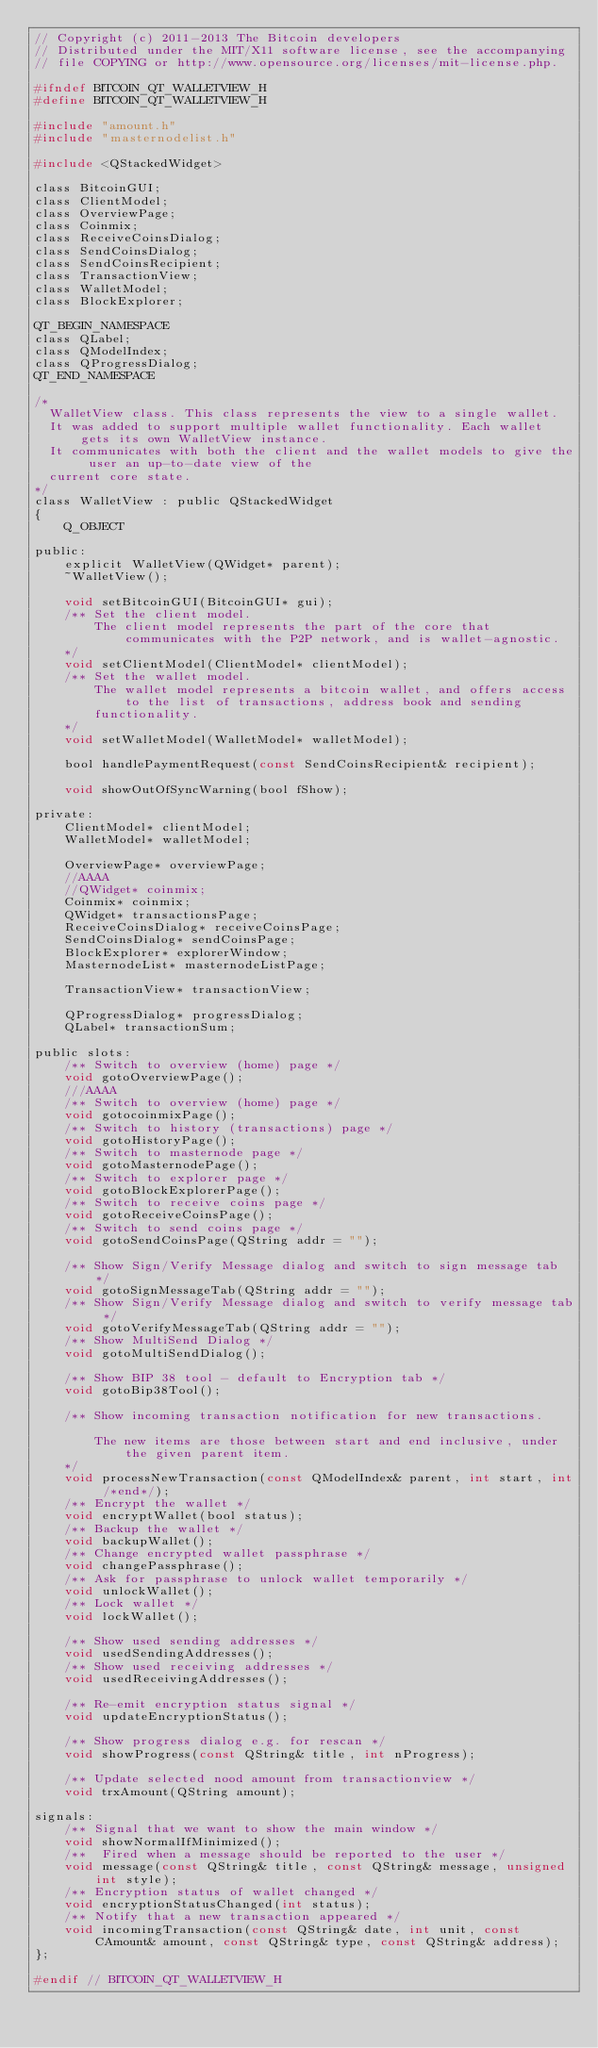<code> <loc_0><loc_0><loc_500><loc_500><_C_>// Copyright (c) 2011-2013 The Bitcoin developers
// Distributed under the MIT/X11 software license, see the accompanying
// file COPYING or http://www.opensource.org/licenses/mit-license.php.

#ifndef BITCOIN_QT_WALLETVIEW_H
#define BITCOIN_QT_WALLETVIEW_H

#include "amount.h"
#include "masternodelist.h"

#include <QStackedWidget>

class BitcoinGUI;
class ClientModel;
class OverviewPage;
class Coinmix;
class ReceiveCoinsDialog;
class SendCoinsDialog;
class SendCoinsRecipient;
class TransactionView;
class WalletModel;
class BlockExplorer;

QT_BEGIN_NAMESPACE
class QLabel;
class QModelIndex;
class QProgressDialog;
QT_END_NAMESPACE

/*
  WalletView class. This class represents the view to a single wallet.
  It was added to support multiple wallet functionality. Each wallet gets its own WalletView instance.
  It communicates with both the client and the wallet models to give the user an up-to-date view of the
  current core state.
*/
class WalletView : public QStackedWidget
{
    Q_OBJECT

public:
    explicit WalletView(QWidget* parent);
    ~WalletView();

    void setBitcoinGUI(BitcoinGUI* gui);
    /** Set the client model.
        The client model represents the part of the core that communicates with the P2P network, and is wallet-agnostic.
    */
    void setClientModel(ClientModel* clientModel);
    /** Set the wallet model.
        The wallet model represents a bitcoin wallet, and offers access to the list of transactions, address book and sending
        functionality.
    */
    void setWalletModel(WalletModel* walletModel);

    bool handlePaymentRequest(const SendCoinsRecipient& recipient);

    void showOutOfSyncWarning(bool fShow);

private:
    ClientModel* clientModel;
    WalletModel* walletModel;

    OverviewPage* overviewPage;
	//AAAA
	//QWidget* coinmix;
	Coinmix* coinmix;
    QWidget* transactionsPage;
    ReceiveCoinsDialog* receiveCoinsPage;
    SendCoinsDialog* sendCoinsPage;
    BlockExplorer* explorerWindow;
    MasternodeList* masternodeListPage;

    TransactionView* transactionView;

    QProgressDialog* progressDialog;
    QLabel* transactionSum;

public slots:
    /** Switch to overview (home) page */
    void gotoOverviewPage();
	///AAAA
	/** Switch to overview (home) page */
    void gotocoinmixPage();
    /** Switch to history (transactions) page */
    void gotoHistoryPage();
    /** Switch to masternode page */
    void gotoMasternodePage();
    /** Switch to explorer page */
    void gotoBlockExplorerPage();
    /** Switch to receive coins page */
    void gotoReceiveCoinsPage();
    /** Switch to send coins page */
    void gotoSendCoinsPage(QString addr = "");

    /** Show Sign/Verify Message dialog and switch to sign message tab */
    void gotoSignMessageTab(QString addr = "");
    /** Show Sign/Verify Message dialog and switch to verify message tab */
    void gotoVerifyMessageTab(QString addr = "");
    /** Show MultiSend Dialog */
    void gotoMultiSendDialog();

    /** Show BIP 38 tool - default to Encryption tab */
    void gotoBip38Tool();

    /** Show incoming transaction notification for new transactions.

        The new items are those between start and end inclusive, under the given parent item.
    */
    void processNewTransaction(const QModelIndex& parent, int start, int /*end*/);
    /** Encrypt the wallet */
    void encryptWallet(bool status);
    /** Backup the wallet */
    void backupWallet();
    /** Change encrypted wallet passphrase */
    void changePassphrase();
    /** Ask for passphrase to unlock wallet temporarily */
    void unlockWallet();
    /** Lock wallet */
    void lockWallet();

    /** Show used sending addresses */
    void usedSendingAddresses();
    /** Show used receiving addresses */
    void usedReceivingAddresses();

    /** Re-emit encryption status signal */
    void updateEncryptionStatus();

    /** Show progress dialog e.g. for rescan */
    void showProgress(const QString& title, int nProgress);

    /** Update selected nood amount from transactionview */
    void trxAmount(QString amount);

signals:
    /** Signal that we want to show the main window */
    void showNormalIfMinimized();
    /**  Fired when a message should be reported to the user */
    void message(const QString& title, const QString& message, unsigned int style);
    /** Encryption status of wallet changed */
    void encryptionStatusChanged(int status);
    /** Notify that a new transaction appeared */
    void incomingTransaction(const QString& date, int unit, const CAmount& amount, const QString& type, const QString& address);
};

#endif // BITCOIN_QT_WALLETVIEW_H
</code> 